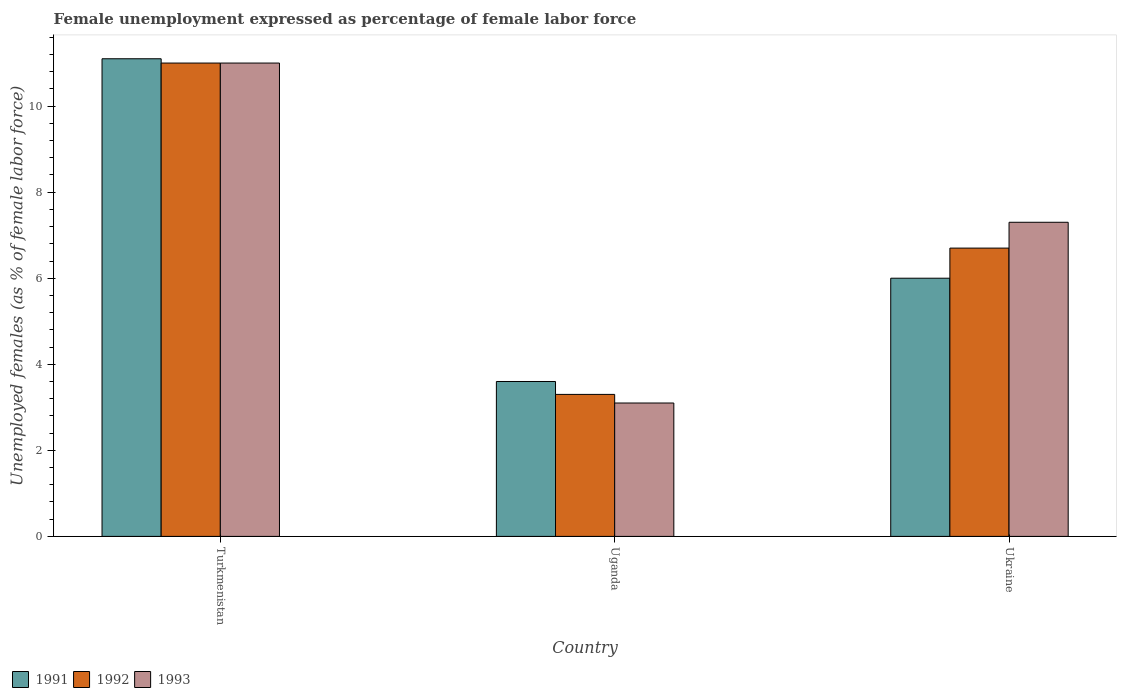How many groups of bars are there?
Offer a terse response. 3. Are the number of bars per tick equal to the number of legend labels?
Your response must be concise. Yes. How many bars are there on the 1st tick from the left?
Make the answer very short. 3. What is the label of the 3rd group of bars from the left?
Offer a terse response. Ukraine. In how many cases, is the number of bars for a given country not equal to the number of legend labels?
Offer a very short reply. 0. What is the unemployment in females in in 1991 in Turkmenistan?
Provide a short and direct response. 11.1. Across all countries, what is the maximum unemployment in females in in 1993?
Your answer should be compact. 11. Across all countries, what is the minimum unemployment in females in in 1992?
Give a very brief answer. 3.3. In which country was the unemployment in females in in 1992 maximum?
Your answer should be very brief. Turkmenistan. In which country was the unemployment in females in in 1992 minimum?
Provide a succinct answer. Uganda. What is the total unemployment in females in in 1993 in the graph?
Provide a succinct answer. 21.4. What is the difference between the unemployment in females in in 1992 in Turkmenistan and that in Ukraine?
Ensure brevity in your answer.  4.3. What is the difference between the unemployment in females in in 1992 in Turkmenistan and the unemployment in females in in 1993 in Uganda?
Your answer should be very brief. 7.9. What is the average unemployment in females in in 1991 per country?
Offer a terse response. 6.9. What is the difference between the unemployment in females in of/in 1993 and unemployment in females in of/in 1991 in Ukraine?
Your answer should be very brief. 1.3. What is the ratio of the unemployment in females in in 1991 in Uganda to that in Ukraine?
Give a very brief answer. 0.6. What is the difference between the highest and the second highest unemployment in females in in 1991?
Make the answer very short. -7.5. What is the difference between the highest and the lowest unemployment in females in in 1993?
Provide a short and direct response. 7.9. In how many countries, is the unemployment in females in in 1991 greater than the average unemployment in females in in 1991 taken over all countries?
Make the answer very short. 1. Is the sum of the unemployment in females in in 1992 in Turkmenistan and Uganda greater than the maximum unemployment in females in in 1993 across all countries?
Offer a very short reply. Yes. What does the 3rd bar from the left in Ukraine represents?
Provide a short and direct response. 1993. How many bars are there?
Provide a succinct answer. 9. Are the values on the major ticks of Y-axis written in scientific E-notation?
Make the answer very short. No. Does the graph contain grids?
Ensure brevity in your answer.  No. Where does the legend appear in the graph?
Provide a short and direct response. Bottom left. What is the title of the graph?
Offer a very short reply. Female unemployment expressed as percentage of female labor force. Does "1973" appear as one of the legend labels in the graph?
Provide a succinct answer. No. What is the label or title of the Y-axis?
Your response must be concise. Unemployed females (as % of female labor force). What is the Unemployed females (as % of female labor force) of 1991 in Turkmenistan?
Provide a short and direct response. 11.1. What is the Unemployed females (as % of female labor force) of 1993 in Turkmenistan?
Give a very brief answer. 11. What is the Unemployed females (as % of female labor force) in 1991 in Uganda?
Keep it short and to the point. 3.6. What is the Unemployed females (as % of female labor force) in 1992 in Uganda?
Keep it short and to the point. 3.3. What is the Unemployed females (as % of female labor force) of 1993 in Uganda?
Your answer should be compact. 3.1. What is the Unemployed females (as % of female labor force) in 1991 in Ukraine?
Provide a succinct answer. 6. What is the Unemployed females (as % of female labor force) in 1992 in Ukraine?
Give a very brief answer. 6.7. What is the Unemployed females (as % of female labor force) in 1993 in Ukraine?
Offer a terse response. 7.3. Across all countries, what is the maximum Unemployed females (as % of female labor force) in 1991?
Make the answer very short. 11.1. Across all countries, what is the maximum Unemployed females (as % of female labor force) of 1992?
Your answer should be very brief. 11. Across all countries, what is the maximum Unemployed females (as % of female labor force) in 1993?
Keep it short and to the point. 11. Across all countries, what is the minimum Unemployed females (as % of female labor force) of 1991?
Your response must be concise. 3.6. Across all countries, what is the minimum Unemployed females (as % of female labor force) in 1992?
Your answer should be very brief. 3.3. Across all countries, what is the minimum Unemployed females (as % of female labor force) of 1993?
Keep it short and to the point. 3.1. What is the total Unemployed females (as % of female labor force) in 1991 in the graph?
Offer a very short reply. 20.7. What is the total Unemployed females (as % of female labor force) of 1993 in the graph?
Give a very brief answer. 21.4. What is the difference between the Unemployed females (as % of female labor force) of 1991 in Turkmenistan and that in Uganda?
Your answer should be very brief. 7.5. What is the difference between the Unemployed females (as % of female labor force) of 1993 in Turkmenistan and that in Uganda?
Offer a very short reply. 7.9. What is the difference between the Unemployed females (as % of female labor force) in 1991 in Turkmenistan and that in Ukraine?
Your answer should be compact. 5.1. What is the difference between the Unemployed females (as % of female labor force) in 1992 in Uganda and that in Ukraine?
Provide a short and direct response. -3.4. What is the difference between the Unemployed females (as % of female labor force) of 1993 in Uganda and that in Ukraine?
Offer a very short reply. -4.2. What is the difference between the Unemployed females (as % of female labor force) of 1992 in Turkmenistan and the Unemployed females (as % of female labor force) of 1993 in Uganda?
Give a very brief answer. 7.9. What is the difference between the Unemployed females (as % of female labor force) of 1991 in Turkmenistan and the Unemployed females (as % of female labor force) of 1992 in Ukraine?
Offer a terse response. 4.4. What is the difference between the Unemployed females (as % of female labor force) of 1991 in Turkmenistan and the Unemployed females (as % of female labor force) of 1993 in Ukraine?
Offer a very short reply. 3.8. What is the difference between the Unemployed females (as % of female labor force) of 1992 in Turkmenistan and the Unemployed females (as % of female labor force) of 1993 in Ukraine?
Your answer should be compact. 3.7. What is the difference between the Unemployed females (as % of female labor force) in 1991 in Uganda and the Unemployed females (as % of female labor force) in 1992 in Ukraine?
Your answer should be compact. -3.1. What is the difference between the Unemployed females (as % of female labor force) of 1991 in Uganda and the Unemployed females (as % of female labor force) of 1993 in Ukraine?
Offer a very short reply. -3.7. What is the average Unemployed females (as % of female labor force) in 1991 per country?
Your answer should be compact. 6.9. What is the average Unemployed females (as % of female labor force) of 1992 per country?
Make the answer very short. 7. What is the average Unemployed females (as % of female labor force) of 1993 per country?
Your answer should be compact. 7.13. What is the difference between the Unemployed females (as % of female labor force) of 1991 and Unemployed females (as % of female labor force) of 1993 in Turkmenistan?
Make the answer very short. 0.1. What is the difference between the Unemployed females (as % of female labor force) in 1992 and Unemployed females (as % of female labor force) in 1993 in Turkmenistan?
Make the answer very short. 0. What is the difference between the Unemployed females (as % of female labor force) of 1991 and Unemployed females (as % of female labor force) of 1992 in Uganda?
Your response must be concise. 0.3. What is the difference between the Unemployed females (as % of female labor force) in 1991 and Unemployed females (as % of female labor force) in 1993 in Uganda?
Your response must be concise. 0.5. What is the ratio of the Unemployed females (as % of female labor force) in 1991 in Turkmenistan to that in Uganda?
Your response must be concise. 3.08. What is the ratio of the Unemployed females (as % of female labor force) in 1993 in Turkmenistan to that in Uganda?
Your response must be concise. 3.55. What is the ratio of the Unemployed females (as % of female labor force) of 1991 in Turkmenistan to that in Ukraine?
Provide a short and direct response. 1.85. What is the ratio of the Unemployed females (as % of female labor force) of 1992 in Turkmenistan to that in Ukraine?
Make the answer very short. 1.64. What is the ratio of the Unemployed females (as % of female labor force) in 1993 in Turkmenistan to that in Ukraine?
Provide a succinct answer. 1.51. What is the ratio of the Unemployed females (as % of female labor force) in 1992 in Uganda to that in Ukraine?
Keep it short and to the point. 0.49. What is the ratio of the Unemployed females (as % of female labor force) of 1993 in Uganda to that in Ukraine?
Make the answer very short. 0.42. What is the difference between the highest and the second highest Unemployed females (as % of female labor force) of 1991?
Provide a succinct answer. 5.1. What is the difference between the highest and the lowest Unemployed females (as % of female labor force) of 1991?
Your answer should be very brief. 7.5. 